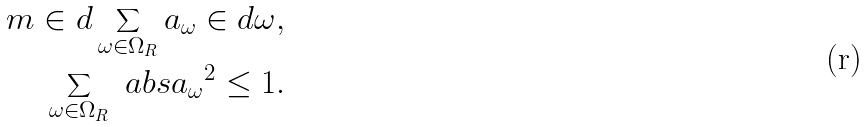<formula> <loc_0><loc_0><loc_500><loc_500>m \in d \sum _ { \omega \in \Omega _ { R } } a _ { \omega } \in d \omega , \\ \sum _ { \omega \in \Omega _ { R } } \ a b s { a _ { \omega } } ^ { 2 } \leq 1 .</formula> 